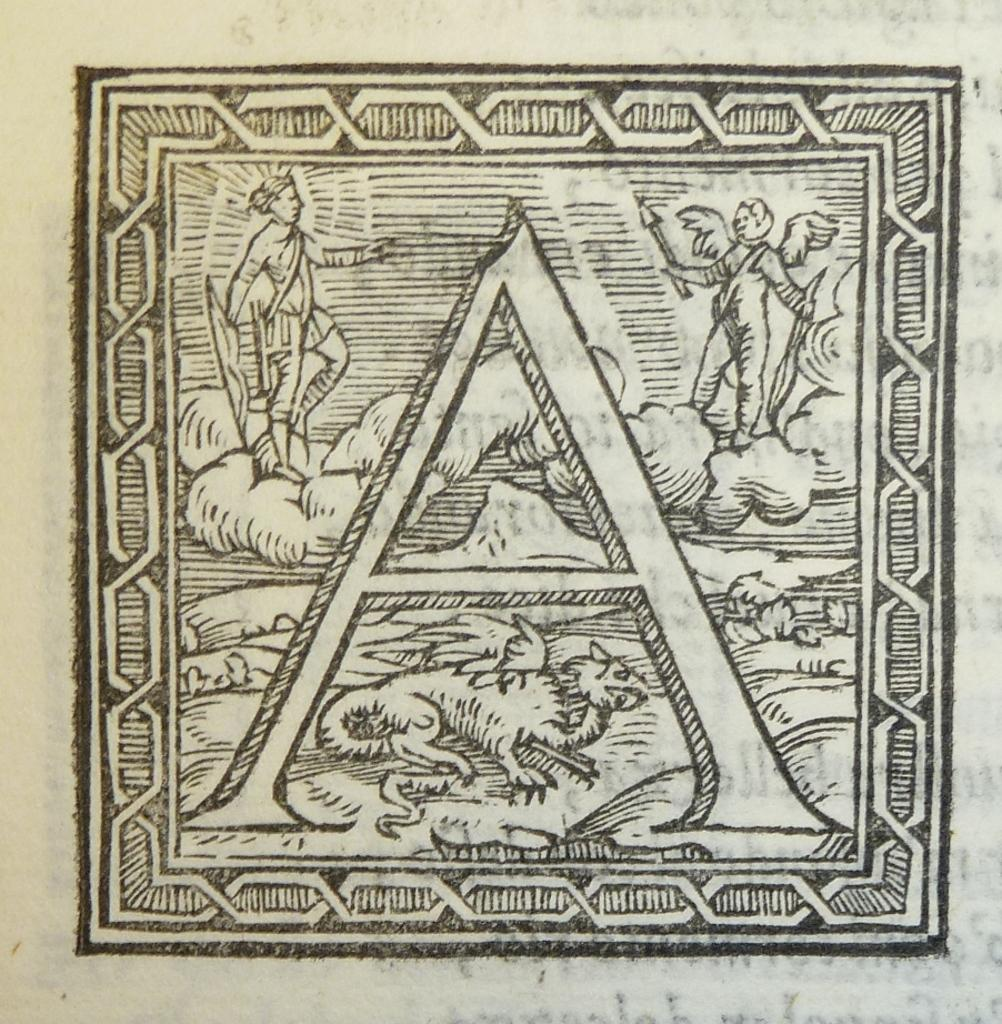What is depicted in the image? There is a sketch in the image. What is included in the sketch? There are people and an animal in the sketch. What type of steam can be seen coming from the field in the image? There is no field or steam present in the image; it features a sketch with people and an animal. 